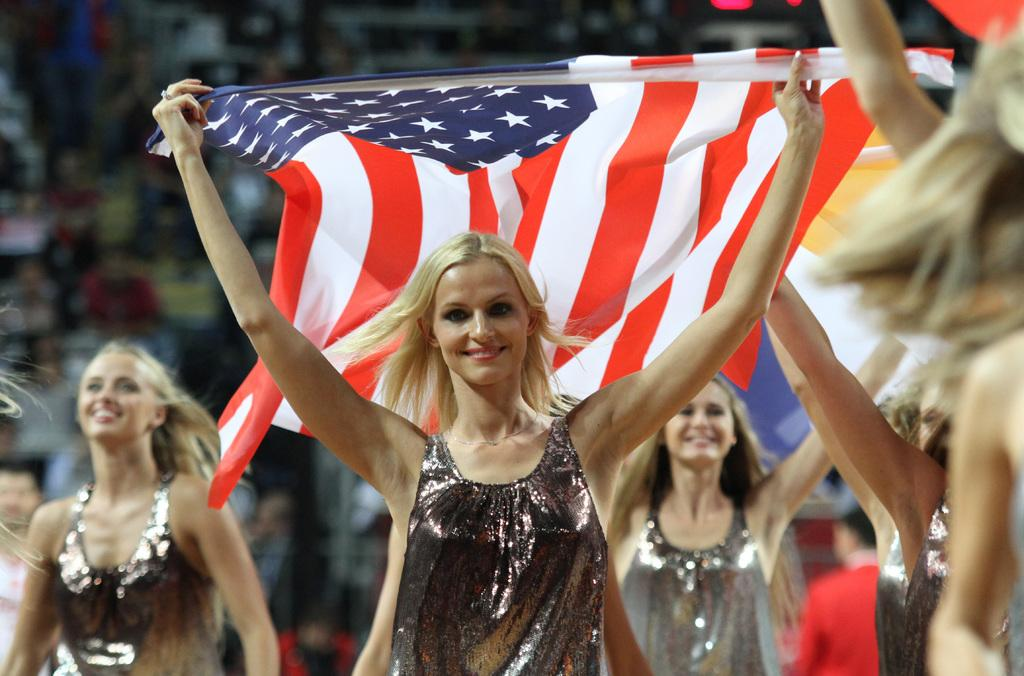What can be seen in the image? There is a group of people in the image. How is the background of the image? The background is blurred. Can you describe the position of a person in the image? There is a person in the middle of the image. What is the person in the middle doing? The person in the middle is holding a hand with her hands. What is the price of the balls in the image? There are no balls present in the image, so it is not possible to determine their price. 